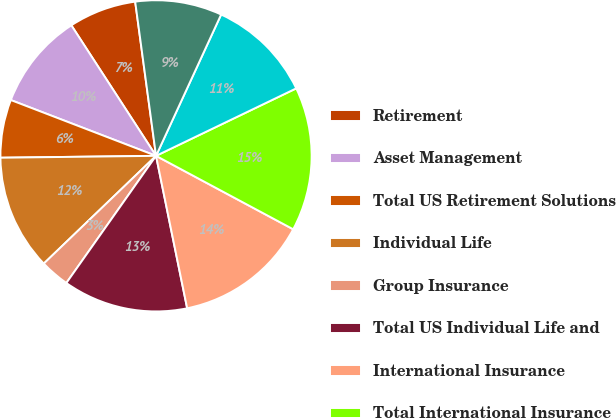Convert chart. <chart><loc_0><loc_0><loc_500><loc_500><pie_chart><fcel>Retirement<fcel>Asset Management<fcel>Total US Retirement Solutions<fcel>Individual Life<fcel>Group Insurance<fcel>Total US Individual Life and<fcel>International Insurance<fcel>Total International Insurance<fcel>Corporate and Other operations<fcel>Total Corporate and Other<nl><fcel>7.02%<fcel>10.0%<fcel>6.03%<fcel>11.98%<fcel>3.05%<fcel>12.98%<fcel>13.97%<fcel>14.96%<fcel>10.99%<fcel>9.01%<nl></chart> 